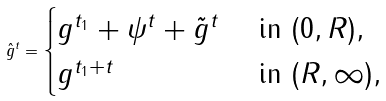<formula> <loc_0><loc_0><loc_500><loc_500>\hat { g } ^ { t } = \begin{cases} g ^ { t _ { 1 } } + \psi ^ { t } + \tilde { g } ^ { t } & \text { in } ( 0 , R ) , \\ g ^ { t _ { 1 } + t } & \text { in } ( R , \infty ) , \end{cases}</formula> 